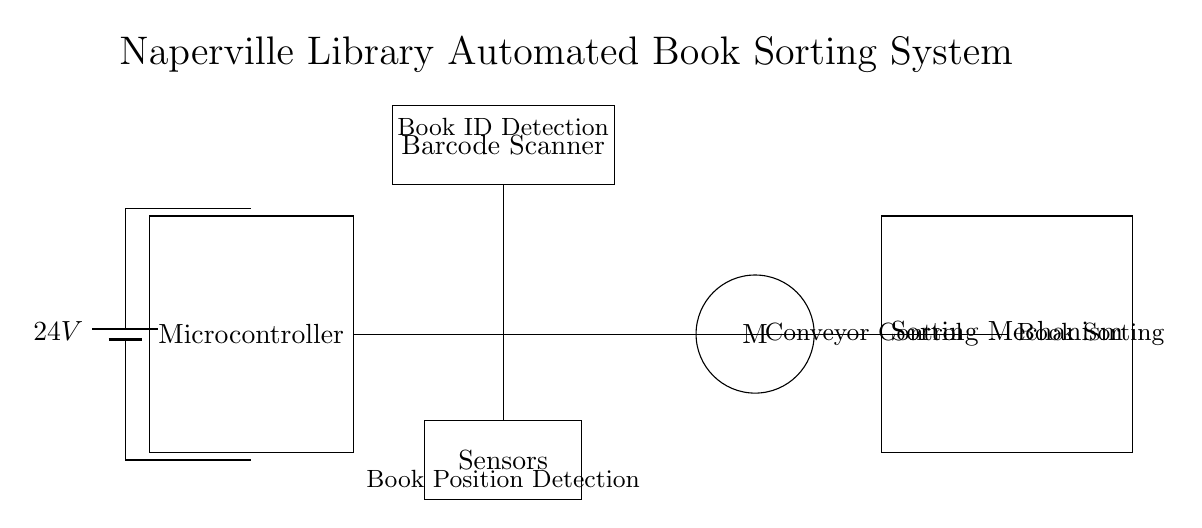What is the main power supply voltage for this system? The diagram shows a battery labeled with a voltage of 24V, indicating the power supply for the system.
Answer: 24V What component controls the conveyor? The circuit diagram specifically shows a component labeled "M" for the motor, indicating it controls the conveyor mechanism for moving books.
Answer: Motor What does the barcode scanner do? The diagram indicates that the barcode scanner is responsible for detecting book IDs, as labeled above the component.
Answer: Book ID Detection How many major components are in the circuit? The diagram includes five major components: power supply, microcontroller, barcode scanner, conveyor motor, and sorting mechanism, thus providing a total count of these distinct parts.
Answer: Five What is the purpose of the sensors in the circuit? The sensors, as indicated in the description, are for detecting the position of books, which is crucial for sorting in the automated system.
Answer: Book Position Detection How is the microcontroller connected to the other components? The microcontroller is connected to all other components via branches indicated by the lines, showing it manages and controls each aspect of the system including scanning, motor functions, sorting, and sensing.
Answer: Via branches/lines What does the sorting mechanism do? The sorting mechanism, as specified in the label, is responsible for sorting the books after they have been scanned and identified by the system.
Answer: Book Sorting 